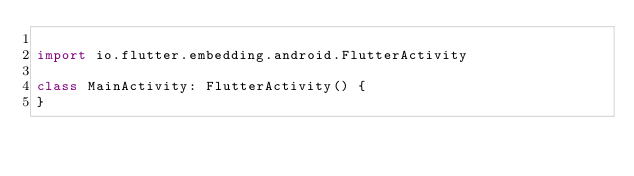Convert code to text. <code><loc_0><loc_0><loc_500><loc_500><_Kotlin_>
import io.flutter.embedding.android.FlutterActivity

class MainActivity: FlutterActivity() {
}
</code> 